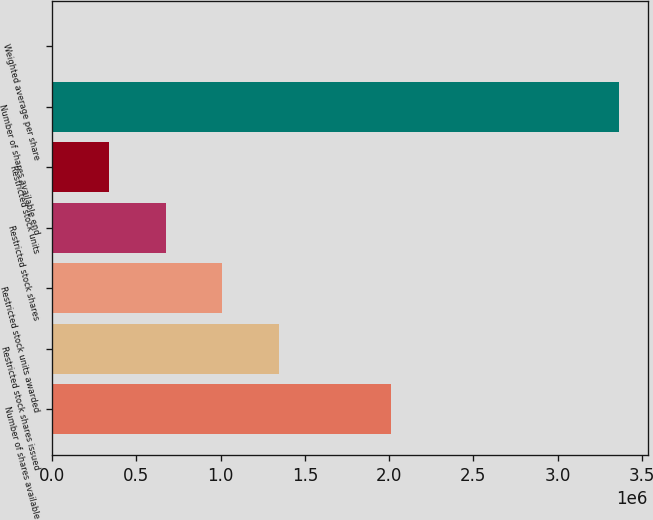Convert chart to OTSL. <chart><loc_0><loc_0><loc_500><loc_500><bar_chart><fcel>Number of shares available<fcel>Restricted stock shares issued<fcel>Restricted stock units awarded<fcel>Restricted stock shares<fcel>Restricted stock units<fcel>Number of shares available end<fcel>Weighted average per share<nl><fcel>2.00915e+06<fcel>1.34602e+06<fcel>1.00952e+06<fcel>673024<fcel>336527<fcel>3.365e+06<fcel>30.54<nl></chart> 